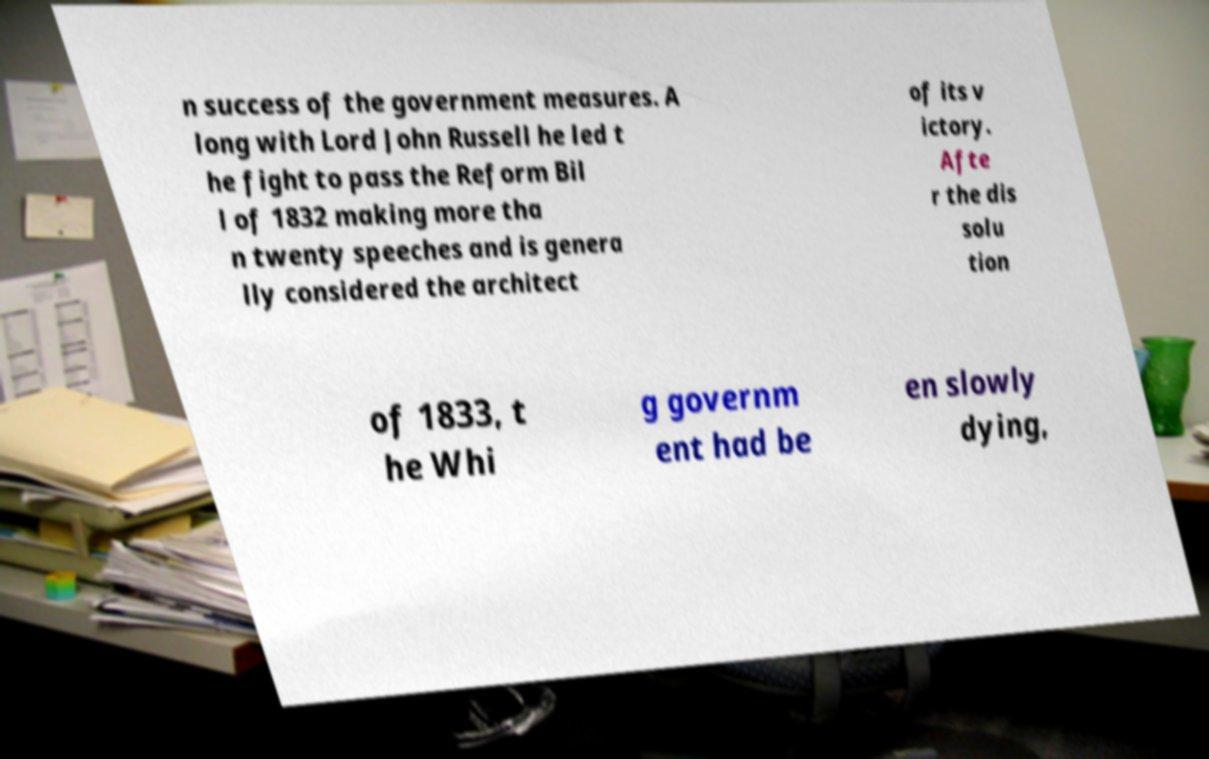For documentation purposes, I need the text within this image transcribed. Could you provide that? n success of the government measures. A long with Lord John Russell he led t he fight to pass the Reform Bil l of 1832 making more tha n twenty speeches and is genera lly considered the architect of its v ictory. Afte r the dis solu tion of 1833, t he Whi g governm ent had be en slowly dying, 